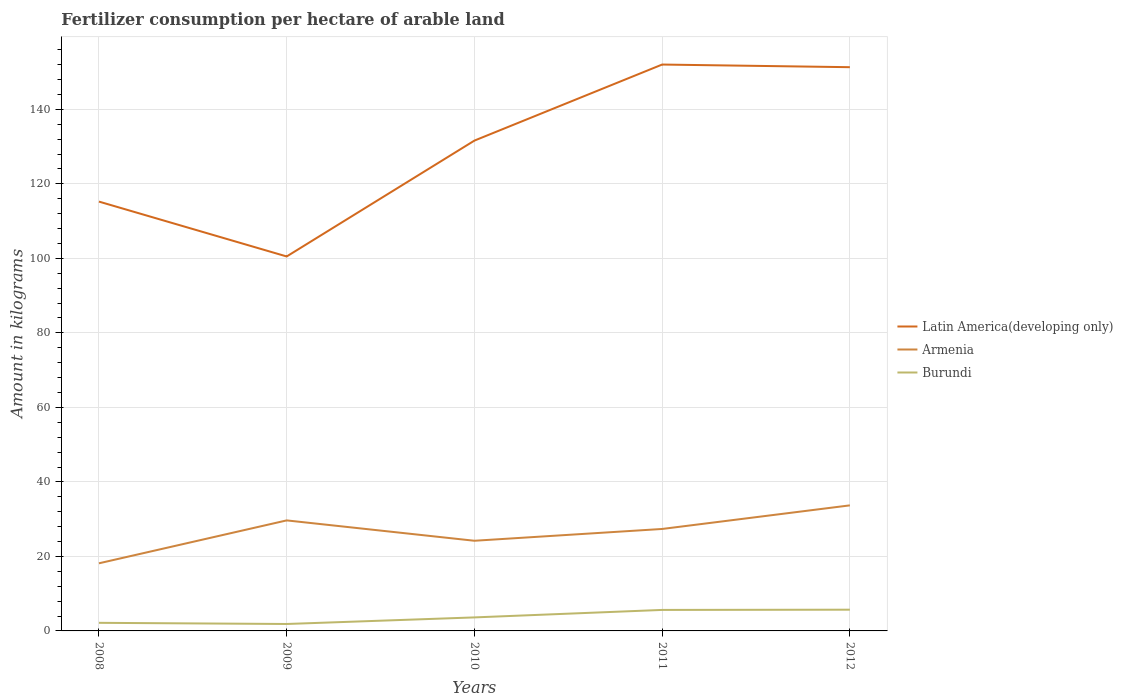Does the line corresponding to Armenia intersect with the line corresponding to Latin America(developing only)?
Offer a terse response. No. Across all years, what is the maximum amount of fertilizer consumption in Burundi?
Your response must be concise. 1.86. In which year was the amount of fertilizer consumption in Latin America(developing only) maximum?
Keep it short and to the point. 2009. What is the total amount of fertilizer consumption in Latin America(developing only) in the graph?
Give a very brief answer. -36.79. What is the difference between the highest and the second highest amount of fertilizer consumption in Armenia?
Your answer should be compact. 15.55. What is the difference between the highest and the lowest amount of fertilizer consumption in Latin America(developing only)?
Keep it short and to the point. 3. How many years are there in the graph?
Provide a succinct answer. 5. What is the difference between two consecutive major ticks on the Y-axis?
Offer a terse response. 20. Where does the legend appear in the graph?
Provide a short and direct response. Center right. How many legend labels are there?
Provide a short and direct response. 3. What is the title of the graph?
Offer a terse response. Fertilizer consumption per hectare of arable land. Does "Romania" appear as one of the legend labels in the graph?
Your response must be concise. No. What is the label or title of the X-axis?
Keep it short and to the point. Years. What is the label or title of the Y-axis?
Your answer should be very brief. Amount in kilograms. What is the Amount in kilograms in Latin America(developing only) in 2008?
Provide a short and direct response. 115.25. What is the Amount in kilograms of Armenia in 2008?
Give a very brief answer. 18.15. What is the Amount in kilograms of Burundi in 2008?
Ensure brevity in your answer.  2.17. What is the Amount in kilograms in Latin America(developing only) in 2009?
Provide a succinct answer. 100.52. What is the Amount in kilograms of Armenia in 2009?
Your answer should be compact. 29.67. What is the Amount in kilograms of Burundi in 2009?
Provide a succinct answer. 1.86. What is the Amount in kilograms of Latin America(developing only) in 2010?
Provide a succinct answer. 131.62. What is the Amount in kilograms of Armenia in 2010?
Your response must be concise. 24.2. What is the Amount in kilograms of Burundi in 2010?
Offer a terse response. 3.63. What is the Amount in kilograms in Latin America(developing only) in 2011?
Keep it short and to the point. 152.03. What is the Amount in kilograms of Armenia in 2011?
Your response must be concise. 27.37. What is the Amount in kilograms of Burundi in 2011?
Keep it short and to the point. 5.63. What is the Amount in kilograms of Latin America(developing only) in 2012?
Your answer should be very brief. 151.32. What is the Amount in kilograms in Armenia in 2012?
Keep it short and to the point. 33.7. What is the Amount in kilograms of Burundi in 2012?
Your response must be concise. 5.7. Across all years, what is the maximum Amount in kilograms of Latin America(developing only)?
Offer a terse response. 152.03. Across all years, what is the maximum Amount in kilograms in Armenia?
Keep it short and to the point. 33.7. Across all years, what is the maximum Amount in kilograms in Burundi?
Make the answer very short. 5.7. Across all years, what is the minimum Amount in kilograms of Latin America(developing only)?
Your response must be concise. 100.52. Across all years, what is the minimum Amount in kilograms in Armenia?
Provide a succinct answer. 18.15. Across all years, what is the minimum Amount in kilograms in Burundi?
Provide a short and direct response. 1.86. What is the total Amount in kilograms of Latin America(developing only) in the graph?
Your answer should be compact. 650.73. What is the total Amount in kilograms in Armenia in the graph?
Keep it short and to the point. 133.09. What is the total Amount in kilograms of Burundi in the graph?
Provide a short and direct response. 18.99. What is the difference between the Amount in kilograms in Latin America(developing only) in 2008 and that in 2009?
Offer a terse response. 14.73. What is the difference between the Amount in kilograms in Armenia in 2008 and that in 2009?
Make the answer very short. -11.52. What is the difference between the Amount in kilograms of Burundi in 2008 and that in 2009?
Your answer should be compact. 0.31. What is the difference between the Amount in kilograms in Latin America(developing only) in 2008 and that in 2010?
Your response must be concise. -16.37. What is the difference between the Amount in kilograms of Armenia in 2008 and that in 2010?
Ensure brevity in your answer.  -6.05. What is the difference between the Amount in kilograms of Burundi in 2008 and that in 2010?
Provide a succinct answer. -1.46. What is the difference between the Amount in kilograms in Latin America(developing only) in 2008 and that in 2011?
Ensure brevity in your answer.  -36.79. What is the difference between the Amount in kilograms in Armenia in 2008 and that in 2011?
Your answer should be compact. -9.22. What is the difference between the Amount in kilograms of Burundi in 2008 and that in 2011?
Your response must be concise. -3.46. What is the difference between the Amount in kilograms of Latin America(developing only) in 2008 and that in 2012?
Your answer should be very brief. -36.08. What is the difference between the Amount in kilograms in Armenia in 2008 and that in 2012?
Provide a short and direct response. -15.55. What is the difference between the Amount in kilograms of Burundi in 2008 and that in 2012?
Offer a terse response. -3.53. What is the difference between the Amount in kilograms in Latin America(developing only) in 2009 and that in 2010?
Your response must be concise. -31.1. What is the difference between the Amount in kilograms in Armenia in 2009 and that in 2010?
Your response must be concise. 5.46. What is the difference between the Amount in kilograms in Burundi in 2009 and that in 2010?
Your response must be concise. -1.77. What is the difference between the Amount in kilograms in Latin America(developing only) in 2009 and that in 2011?
Give a very brief answer. -51.52. What is the difference between the Amount in kilograms in Armenia in 2009 and that in 2011?
Give a very brief answer. 2.3. What is the difference between the Amount in kilograms of Burundi in 2009 and that in 2011?
Ensure brevity in your answer.  -3.77. What is the difference between the Amount in kilograms of Latin America(developing only) in 2009 and that in 2012?
Your response must be concise. -50.81. What is the difference between the Amount in kilograms in Armenia in 2009 and that in 2012?
Give a very brief answer. -4.04. What is the difference between the Amount in kilograms of Burundi in 2009 and that in 2012?
Provide a short and direct response. -3.84. What is the difference between the Amount in kilograms in Latin America(developing only) in 2010 and that in 2011?
Your answer should be compact. -20.42. What is the difference between the Amount in kilograms in Armenia in 2010 and that in 2011?
Offer a very short reply. -3.17. What is the difference between the Amount in kilograms of Burundi in 2010 and that in 2011?
Your answer should be very brief. -2.01. What is the difference between the Amount in kilograms of Latin America(developing only) in 2010 and that in 2012?
Offer a very short reply. -19.71. What is the difference between the Amount in kilograms in Armenia in 2010 and that in 2012?
Make the answer very short. -9.5. What is the difference between the Amount in kilograms in Burundi in 2010 and that in 2012?
Make the answer very short. -2.07. What is the difference between the Amount in kilograms of Latin America(developing only) in 2011 and that in 2012?
Make the answer very short. 0.71. What is the difference between the Amount in kilograms of Armenia in 2011 and that in 2012?
Your answer should be compact. -6.34. What is the difference between the Amount in kilograms in Burundi in 2011 and that in 2012?
Ensure brevity in your answer.  -0.06. What is the difference between the Amount in kilograms of Latin America(developing only) in 2008 and the Amount in kilograms of Armenia in 2009?
Keep it short and to the point. 85.58. What is the difference between the Amount in kilograms of Latin America(developing only) in 2008 and the Amount in kilograms of Burundi in 2009?
Ensure brevity in your answer.  113.38. What is the difference between the Amount in kilograms in Armenia in 2008 and the Amount in kilograms in Burundi in 2009?
Offer a terse response. 16.29. What is the difference between the Amount in kilograms in Latin America(developing only) in 2008 and the Amount in kilograms in Armenia in 2010?
Keep it short and to the point. 91.04. What is the difference between the Amount in kilograms of Latin America(developing only) in 2008 and the Amount in kilograms of Burundi in 2010?
Provide a succinct answer. 111.62. What is the difference between the Amount in kilograms of Armenia in 2008 and the Amount in kilograms of Burundi in 2010?
Keep it short and to the point. 14.52. What is the difference between the Amount in kilograms of Latin America(developing only) in 2008 and the Amount in kilograms of Armenia in 2011?
Offer a terse response. 87.88. What is the difference between the Amount in kilograms of Latin America(developing only) in 2008 and the Amount in kilograms of Burundi in 2011?
Keep it short and to the point. 109.61. What is the difference between the Amount in kilograms in Armenia in 2008 and the Amount in kilograms in Burundi in 2011?
Keep it short and to the point. 12.52. What is the difference between the Amount in kilograms in Latin America(developing only) in 2008 and the Amount in kilograms in Armenia in 2012?
Ensure brevity in your answer.  81.54. What is the difference between the Amount in kilograms in Latin America(developing only) in 2008 and the Amount in kilograms in Burundi in 2012?
Give a very brief answer. 109.55. What is the difference between the Amount in kilograms of Armenia in 2008 and the Amount in kilograms of Burundi in 2012?
Ensure brevity in your answer.  12.45. What is the difference between the Amount in kilograms in Latin America(developing only) in 2009 and the Amount in kilograms in Armenia in 2010?
Your answer should be compact. 76.31. What is the difference between the Amount in kilograms of Latin America(developing only) in 2009 and the Amount in kilograms of Burundi in 2010?
Offer a very short reply. 96.89. What is the difference between the Amount in kilograms in Armenia in 2009 and the Amount in kilograms in Burundi in 2010?
Ensure brevity in your answer.  26.04. What is the difference between the Amount in kilograms of Latin America(developing only) in 2009 and the Amount in kilograms of Armenia in 2011?
Make the answer very short. 73.15. What is the difference between the Amount in kilograms of Latin America(developing only) in 2009 and the Amount in kilograms of Burundi in 2011?
Give a very brief answer. 94.88. What is the difference between the Amount in kilograms in Armenia in 2009 and the Amount in kilograms in Burundi in 2011?
Ensure brevity in your answer.  24.03. What is the difference between the Amount in kilograms of Latin America(developing only) in 2009 and the Amount in kilograms of Armenia in 2012?
Offer a terse response. 66.81. What is the difference between the Amount in kilograms of Latin America(developing only) in 2009 and the Amount in kilograms of Burundi in 2012?
Offer a terse response. 94.82. What is the difference between the Amount in kilograms in Armenia in 2009 and the Amount in kilograms in Burundi in 2012?
Make the answer very short. 23.97. What is the difference between the Amount in kilograms of Latin America(developing only) in 2010 and the Amount in kilograms of Armenia in 2011?
Give a very brief answer. 104.25. What is the difference between the Amount in kilograms of Latin America(developing only) in 2010 and the Amount in kilograms of Burundi in 2011?
Offer a very short reply. 125.98. What is the difference between the Amount in kilograms of Armenia in 2010 and the Amount in kilograms of Burundi in 2011?
Give a very brief answer. 18.57. What is the difference between the Amount in kilograms in Latin America(developing only) in 2010 and the Amount in kilograms in Armenia in 2012?
Offer a terse response. 97.91. What is the difference between the Amount in kilograms in Latin America(developing only) in 2010 and the Amount in kilograms in Burundi in 2012?
Offer a terse response. 125.92. What is the difference between the Amount in kilograms of Armenia in 2010 and the Amount in kilograms of Burundi in 2012?
Keep it short and to the point. 18.5. What is the difference between the Amount in kilograms of Latin America(developing only) in 2011 and the Amount in kilograms of Armenia in 2012?
Make the answer very short. 118.33. What is the difference between the Amount in kilograms in Latin America(developing only) in 2011 and the Amount in kilograms in Burundi in 2012?
Keep it short and to the point. 146.33. What is the difference between the Amount in kilograms of Armenia in 2011 and the Amount in kilograms of Burundi in 2012?
Give a very brief answer. 21.67. What is the average Amount in kilograms of Latin America(developing only) per year?
Provide a succinct answer. 130.15. What is the average Amount in kilograms of Armenia per year?
Provide a succinct answer. 26.62. What is the average Amount in kilograms in Burundi per year?
Offer a terse response. 3.8. In the year 2008, what is the difference between the Amount in kilograms in Latin America(developing only) and Amount in kilograms in Armenia?
Your answer should be very brief. 97.09. In the year 2008, what is the difference between the Amount in kilograms of Latin America(developing only) and Amount in kilograms of Burundi?
Make the answer very short. 113.07. In the year 2008, what is the difference between the Amount in kilograms of Armenia and Amount in kilograms of Burundi?
Provide a short and direct response. 15.98. In the year 2009, what is the difference between the Amount in kilograms of Latin America(developing only) and Amount in kilograms of Armenia?
Your answer should be very brief. 70.85. In the year 2009, what is the difference between the Amount in kilograms of Latin America(developing only) and Amount in kilograms of Burundi?
Provide a succinct answer. 98.65. In the year 2009, what is the difference between the Amount in kilograms in Armenia and Amount in kilograms in Burundi?
Offer a very short reply. 27.81. In the year 2010, what is the difference between the Amount in kilograms of Latin America(developing only) and Amount in kilograms of Armenia?
Your answer should be compact. 107.41. In the year 2010, what is the difference between the Amount in kilograms of Latin America(developing only) and Amount in kilograms of Burundi?
Provide a succinct answer. 127.99. In the year 2010, what is the difference between the Amount in kilograms in Armenia and Amount in kilograms in Burundi?
Give a very brief answer. 20.58. In the year 2011, what is the difference between the Amount in kilograms in Latin America(developing only) and Amount in kilograms in Armenia?
Provide a short and direct response. 124.66. In the year 2011, what is the difference between the Amount in kilograms in Latin America(developing only) and Amount in kilograms in Burundi?
Make the answer very short. 146.4. In the year 2011, what is the difference between the Amount in kilograms in Armenia and Amount in kilograms in Burundi?
Provide a short and direct response. 21.73. In the year 2012, what is the difference between the Amount in kilograms of Latin America(developing only) and Amount in kilograms of Armenia?
Your response must be concise. 117.62. In the year 2012, what is the difference between the Amount in kilograms in Latin America(developing only) and Amount in kilograms in Burundi?
Give a very brief answer. 145.62. In the year 2012, what is the difference between the Amount in kilograms in Armenia and Amount in kilograms in Burundi?
Provide a succinct answer. 28.01. What is the ratio of the Amount in kilograms of Latin America(developing only) in 2008 to that in 2009?
Offer a very short reply. 1.15. What is the ratio of the Amount in kilograms in Armenia in 2008 to that in 2009?
Ensure brevity in your answer.  0.61. What is the ratio of the Amount in kilograms in Burundi in 2008 to that in 2009?
Your response must be concise. 1.17. What is the ratio of the Amount in kilograms in Latin America(developing only) in 2008 to that in 2010?
Give a very brief answer. 0.88. What is the ratio of the Amount in kilograms of Armenia in 2008 to that in 2010?
Offer a terse response. 0.75. What is the ratio of the Amount in kilograms of Burundi in 2008 to that in 2010?
Keep it short and to the point. 0.6. What is the ratio of the Amount in kilograms of Latin America(developing only) in 2008 to that in 2011?
Make the answer very short. 0.76. What is the ratio of the Amount in kilograms in Armenia in 2008 to that in 2011?
Keep it short and to the point. 0.66. What is the ratio of the Amount in kilograms in Burundi in 2008 to that in 2011?
Give a very brief answer. 0.39. What is the ratio of the Amount in kilograms in Latin America(developing only) in 2008 to that in 2012?
Ensure brevity in your answer.  0.76. What is the ratio of the Amount in kilograms of Armenia in 2008 to that in 2012?
Ensure brevity in your answer.  0.54. What is the ratio of the Amount in kilograms in Burundi in 2008 to that in 2012?
Give a very brief answer. 0.38. What is the ratio of the Amount in kilograms in Latin America(developing only) in 2009 to that in 2010?
Provide a short and direct response. 0.76. What is the ratio of the Amount in kilograms in Armenia in 2009 to that in 2010?
Provide a succinct answer. 1.23. What is the ratio of the Amount in kilograms of Burundi in 2009 to that in 2010?
Provide a succinct answer. 0.51. What is the ratio of the Amount in kilograms in Latin America(developing only) in 2009 to that in 2011?
Provide a short and direct response. 0.66. What is the ratio of the Amount in kilograms of Armenia in 2009 to that in 2011?
Offer a very short reply. 1.08. What is the ratio of the Amount in kilograms of Burundi in 2009 to that in 2011?
Keep it short and to the point. 0.33. What is the ratio of the Amount in kilograms of Latin America(developing only) in 2009 to that in 2012?
Give a very brief answer. 0.66. What is the ratio of the Amount in kilograms in Armenia in 2009 to that in 2012?
Offer a very short reply. 0.88. What is the ratio of the Amount in kilograms in Burundi in 2009 to that in 2012?
Offer a very short reply. 0.33. What is the ratio of the Amount in kilograms in Latin America(developing only) in 2010 to that in 2011?
Offer a terse response. 0.87. What is the ratio of the Amount in kilograms in Armenia in 2010 to that in 2011?
Give a very brief answer. 0.88. What is the ratio of the Amount in kilograms in Burundi in 2010 to that in 2011?
Ensure brevity in your answer.  0.64. What is the ratio of the Amount in kilograms of Latin America(developing only) in 2010 to that in 2012?
Your response must be concise. 0.87. What is the ratio of the Amount in kilograms in Armenia in 2010 to that in 2012?
Give a very brief answer. 0.72. What is the ratio of the Amount in kilograms of Burundi in 2010 to that in 2012?
Provide a short and direct response. 0.64. What is the ratio of the Amount in kilograms of Latin America(developing only) in 2011 to that in 2012?
Provide a short and direct response. 1. What is the ratio of the Amount in kilograms of Armenia in 2011 to that in 2012?
Make the answer very short. 0.81. What is the difference between the highest and the second highest Amount in kilograms of Latin America(developing only)?
Ensure brevity in your answer.  0.71. What is the difference between the highest and the second highest Amount in kilograms in Armenia?
Ensure brevity in your answer.  4.04. What is the difference between the highest and the second highest Amount in kilograms in Burundi?
Give a very brief answer. 0.06. What is the difference between the highest and the lowest Amount in kilograms in Latin America(developing only)?
Provide a short and direct response. 51.52. What is the difference between the highest and the lowest Amount in kilograms in Armenia?
Your response must be concise. 15.55. What is the difference between the highest and the lowest Amount in kilograms of Burundi?
Provide a short and direct response. 3.84. 